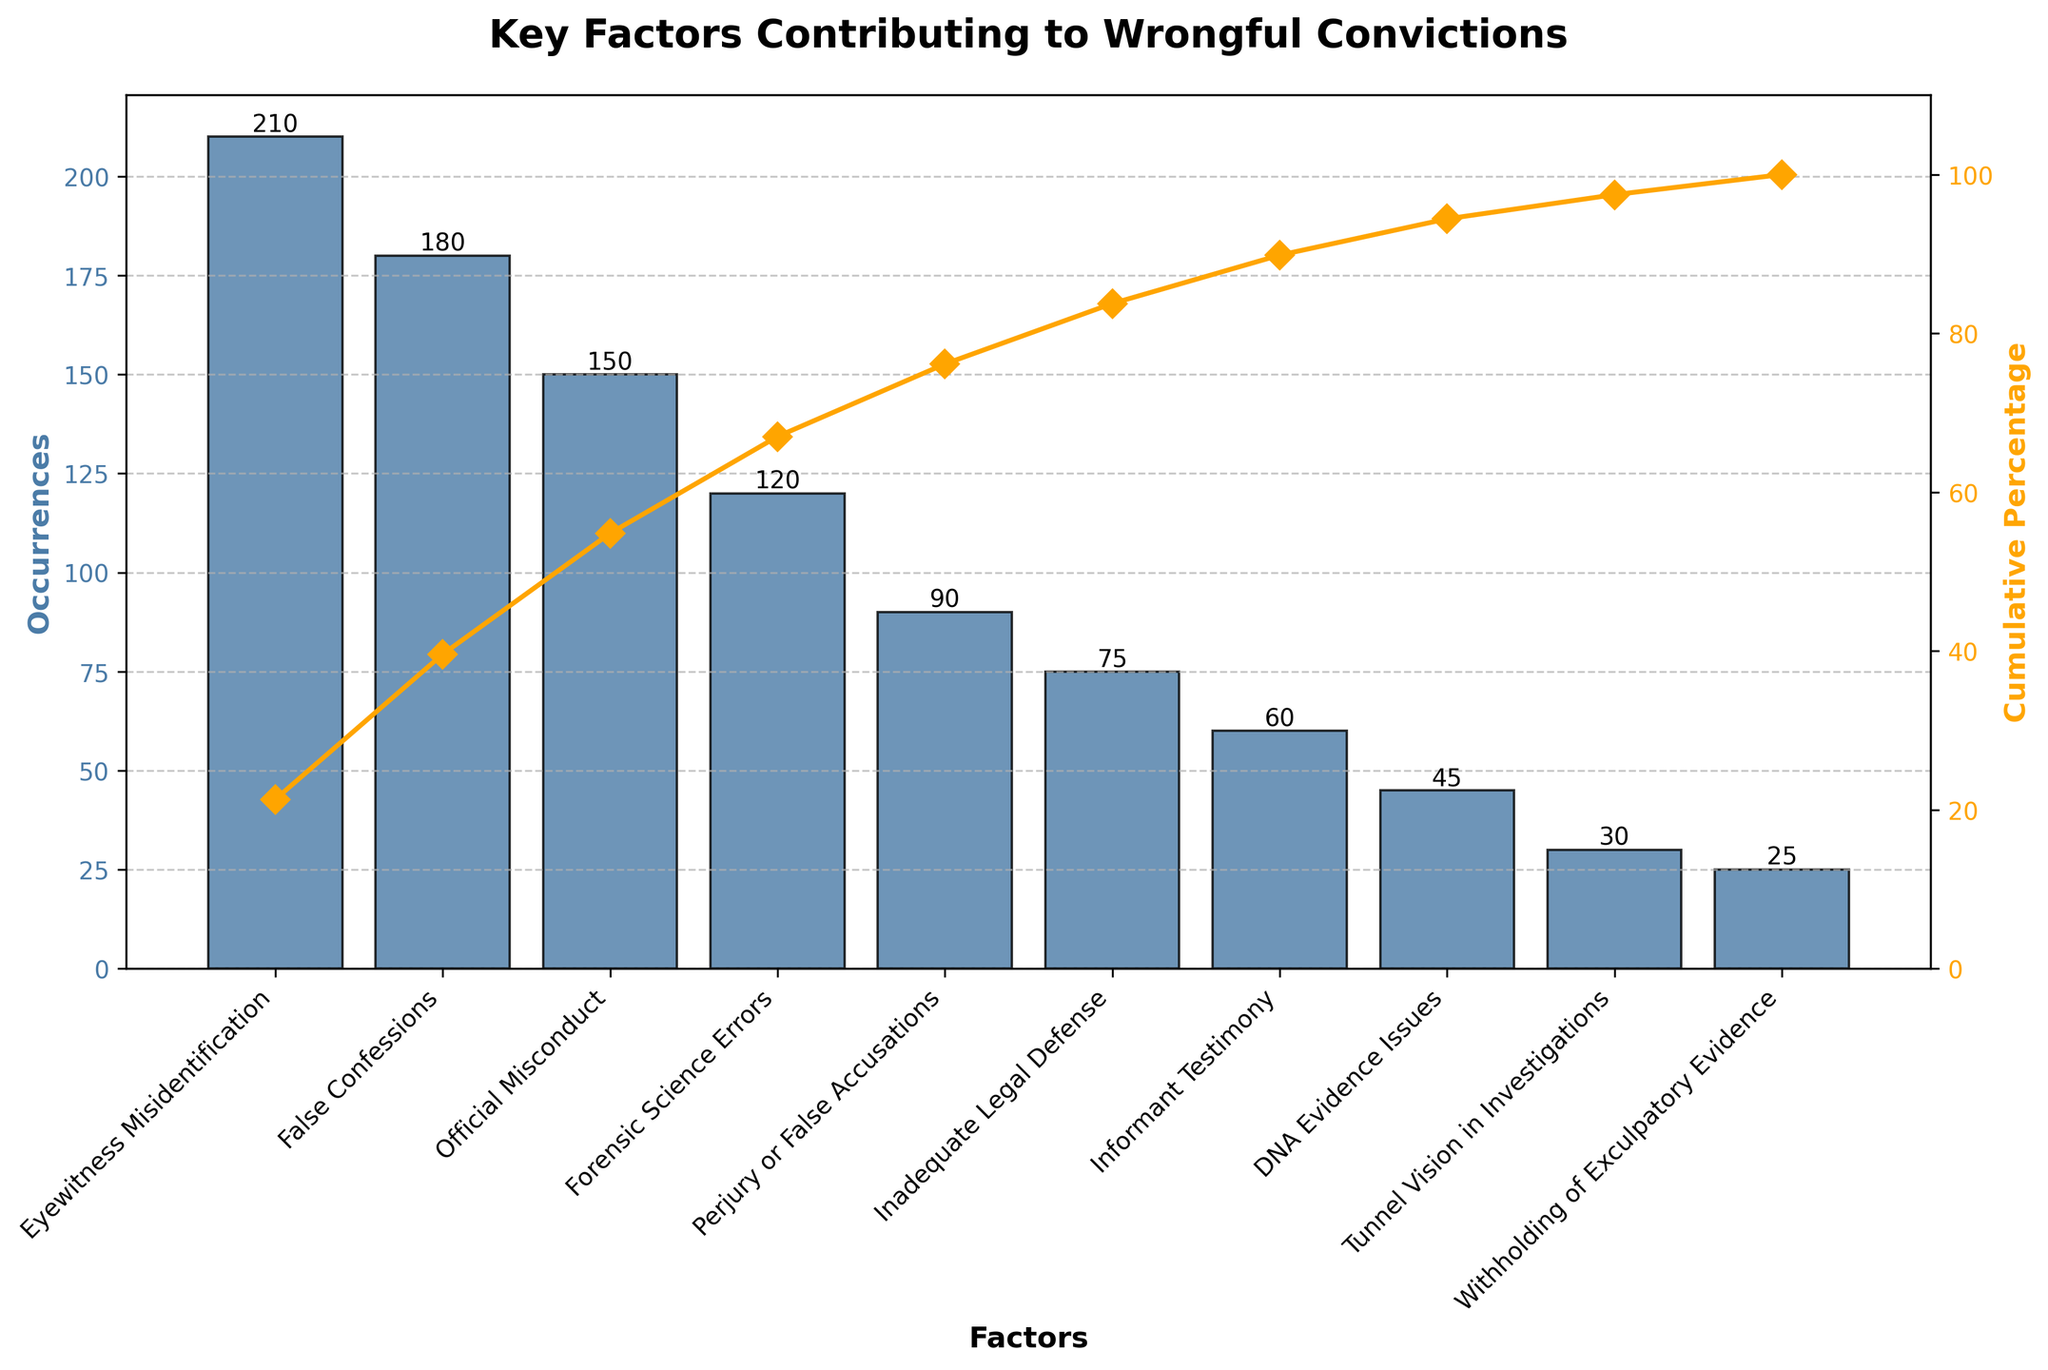What is the title of the figure? The title is displayed at the top of the figure. It reads 'Key Factors Contributing to Wrongful Convictions' in bold.
Answer: Key Factors Contributing to Wrongful Convictions What is the factor with the highest occurrences? To determine which factor has the highest occurrences, look at the tallest bar in the Pareto chart. The factor represented by this bar is 'Eyewitness Misidentification'.
Answer: Eyewitness Misidentification How many occurrences are attributed to False Confessions? Observe the bar labeled 'False Confessions' and note the number above or alongside it. The height indicates the occurrences, which is 180.
Answer: 180 Which factor ranks third in terms of occurrences? Scan the bars in descending order of height. The third tallest bar represents the third-ranked factor, which is 'Official Misconduct'.
Answer: Official Misconduct What is the cumulative percentage after the top two factors? Sum the occurrences of the top two factors and compute their cumulative percentage. 'Eyewitness Misidentification' is 210, and 'False Confessions' is 180. (210 + 180) = 390. To find the cumulative percentage: (390 / (total sum of occurrences)) * 100. The total sum of occurrences is 1,015 (adding up all occurrences). So, (390 / 1,015) * 100 ≈ 38.42%.
Answer: Approximately 38.42% Which factor has fewer occurrences: Perjury or False Accusations, or Inadequate Legal Defense? Compare the heights of the bars for 'Perjury or False Accusations' and 'Inadequate Legal Defense'. The 'Inadequate Legal Defense' bar is shorter, indicating fewer occurrences (75 compared to 90).
Answer: Inadequate Legal Defense What is the cumulative percentage line color? The cumulative percentage line is plotted with a color, indicated by the line in the figure. This color is orange.
Answer: Orange What is the combined total of occurrences for the top three factors? Add the occurrences of the top three factors: 'Eyewitness Misidentification' (210), 'False Confessions' (180), and 'Official Misconduct' (150). (210 + 180 + 150) = 540.
Answer: 540 How many factors have occurrences greater than 100? Count the number of bars taller than the mark representing 100 on the y-axis. These factors are 'Eyewitness Misidentification' (210), 'False Confessions' (180), 'Official Misconduct' (150), and 'Forensic Science Errors' (120), totaling four.
Answer: Four What are the occurrences of the least contributing factor? Identify the shortest bar on the chart, which represents the least occurring factor. The factor is 'Withholding of Exculpatory Evidence', with 25 occurrences.
Answer: 25 